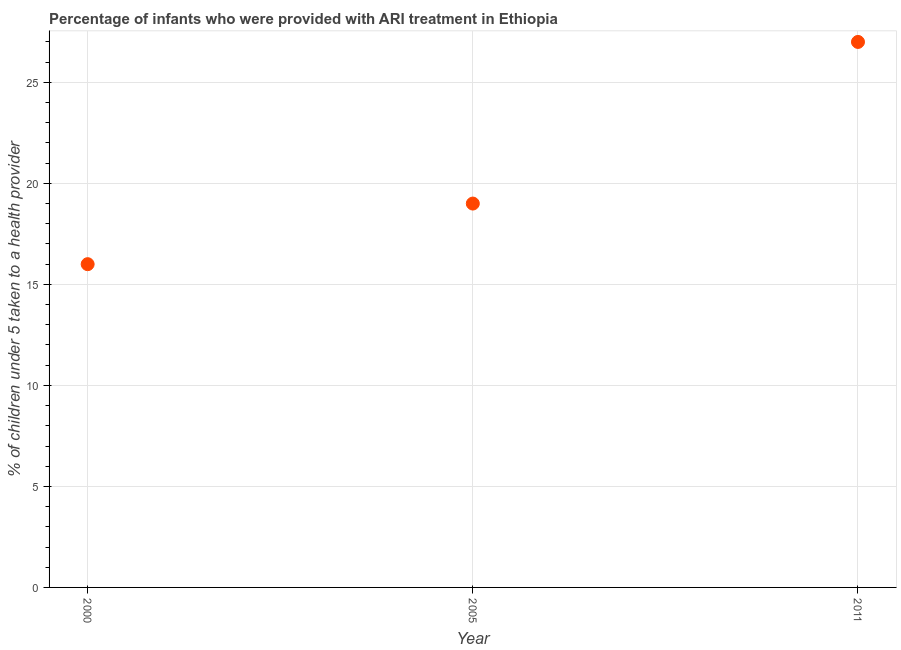What is the percentage of children who were provided with ari treatment in 2005?
Offer a terse response. 19. Across all years, what is the maximum percentage of children who were provided with ari treatment?
Make the answer very short. 27. Across all years, what is the minimum percentage of children who were provided with ari treatment?
Ensure brevity in your answer.  16. In which year was the percentage of children who were provided with ari treatment maximum?
Keep it short and to the point. 2011. What is the sum of the percentage of children who were provided with ari treatment?
Provide a short and direct response. 62. What is the difference between the percentage of children who were provided with ari treatment in 2000 and 2011?
Ensure brevity in your answer.  -11. What is the average percentage of children who were provided with ari treatment per year?
Your answer should be very brief. 20.67. In how many years, is the percentage of children who were provided with ari treatment greater than 3 %?
Your response must be concise. 3. What is the ratio of the percentage of children who were provided with ari treatment in 2005 to that in 2011?
Your response must be concise. 0.7. Is the percentage of children who were provided with ari treatment in 2005 less than that in 2011?
Give a very brief answer. Yes. Is the sum of the percentage of children who were provided with ari treatment in 2000 and 2011 greater than the maximum percentage of children who were provided with ari treatment across all years?
Offer a terse response. Yes. What is the difference between the highest and the lowest percentage of children who were provided with ari treatment?
Your answer should be compact. 11. In how many years, is the percentage of children who were provided with ari treatment greater than the average percentage of children who were provided with ari treatment taken over all years?
Provide a short and direct response. 1. Does the percentage of children who were provided with ari treatment monotonically increase over the years?
Keep it short and to the point. Yes. How many dotlines are there?
Ensure brevity in your answer.  1. What is the difference between two consecutive major ticks on the Y-axis?
Give a very brief answer. 5. Are the values on the major ticks of Y-axis written in scientific E-notation?
Provide a succinct answer. No. Does the graph contain any zero values?
Provide a succinct answer. No. What is the title of the graph?
Give a very brief answer. Percentage of infants who were provided with ARI treatment in Ethiopia. What is the label or title of the Y-axis?
Offer a very short reply. % of children under 5 taken to a health provider. What is the difference between the % of children under 5 taken to a health provider in 2000 and 2005?
Offer a very short reply. -3. What is the difference between the % of children under 5 taken to a health provider in 2000 and 2011?
Make the answer very short. -11. What is the ratio of the % of children under 5 taken to a health provider in 2000 to that in 2005?
Keep it short and to the point. 0.84. What is the ratio of the % of children under 5 taken to a health provider in 2000 to that in 2011?
Your answer should be very brief. 0.59. What is the ratio of the % of children under 5 taken to a health provider in 2005 to that in 2011?
Provide a short and direct response. 0.7. 